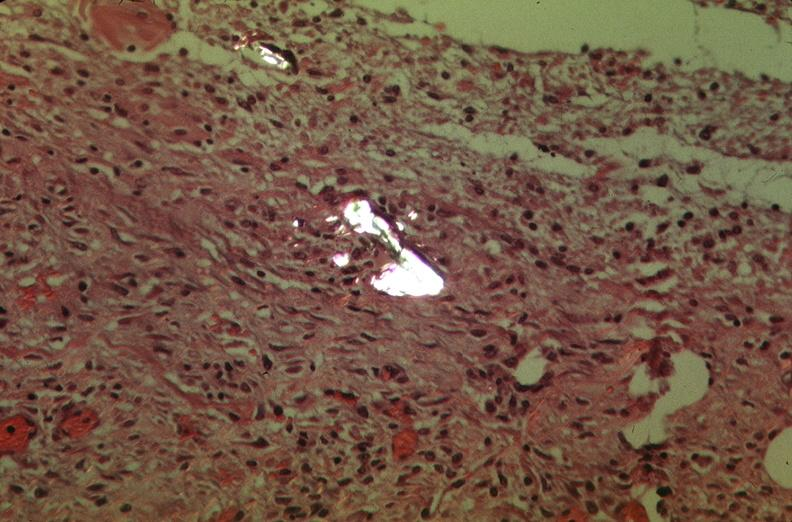what does this image show?
Answer the question using a single word or phrase. Pleura 